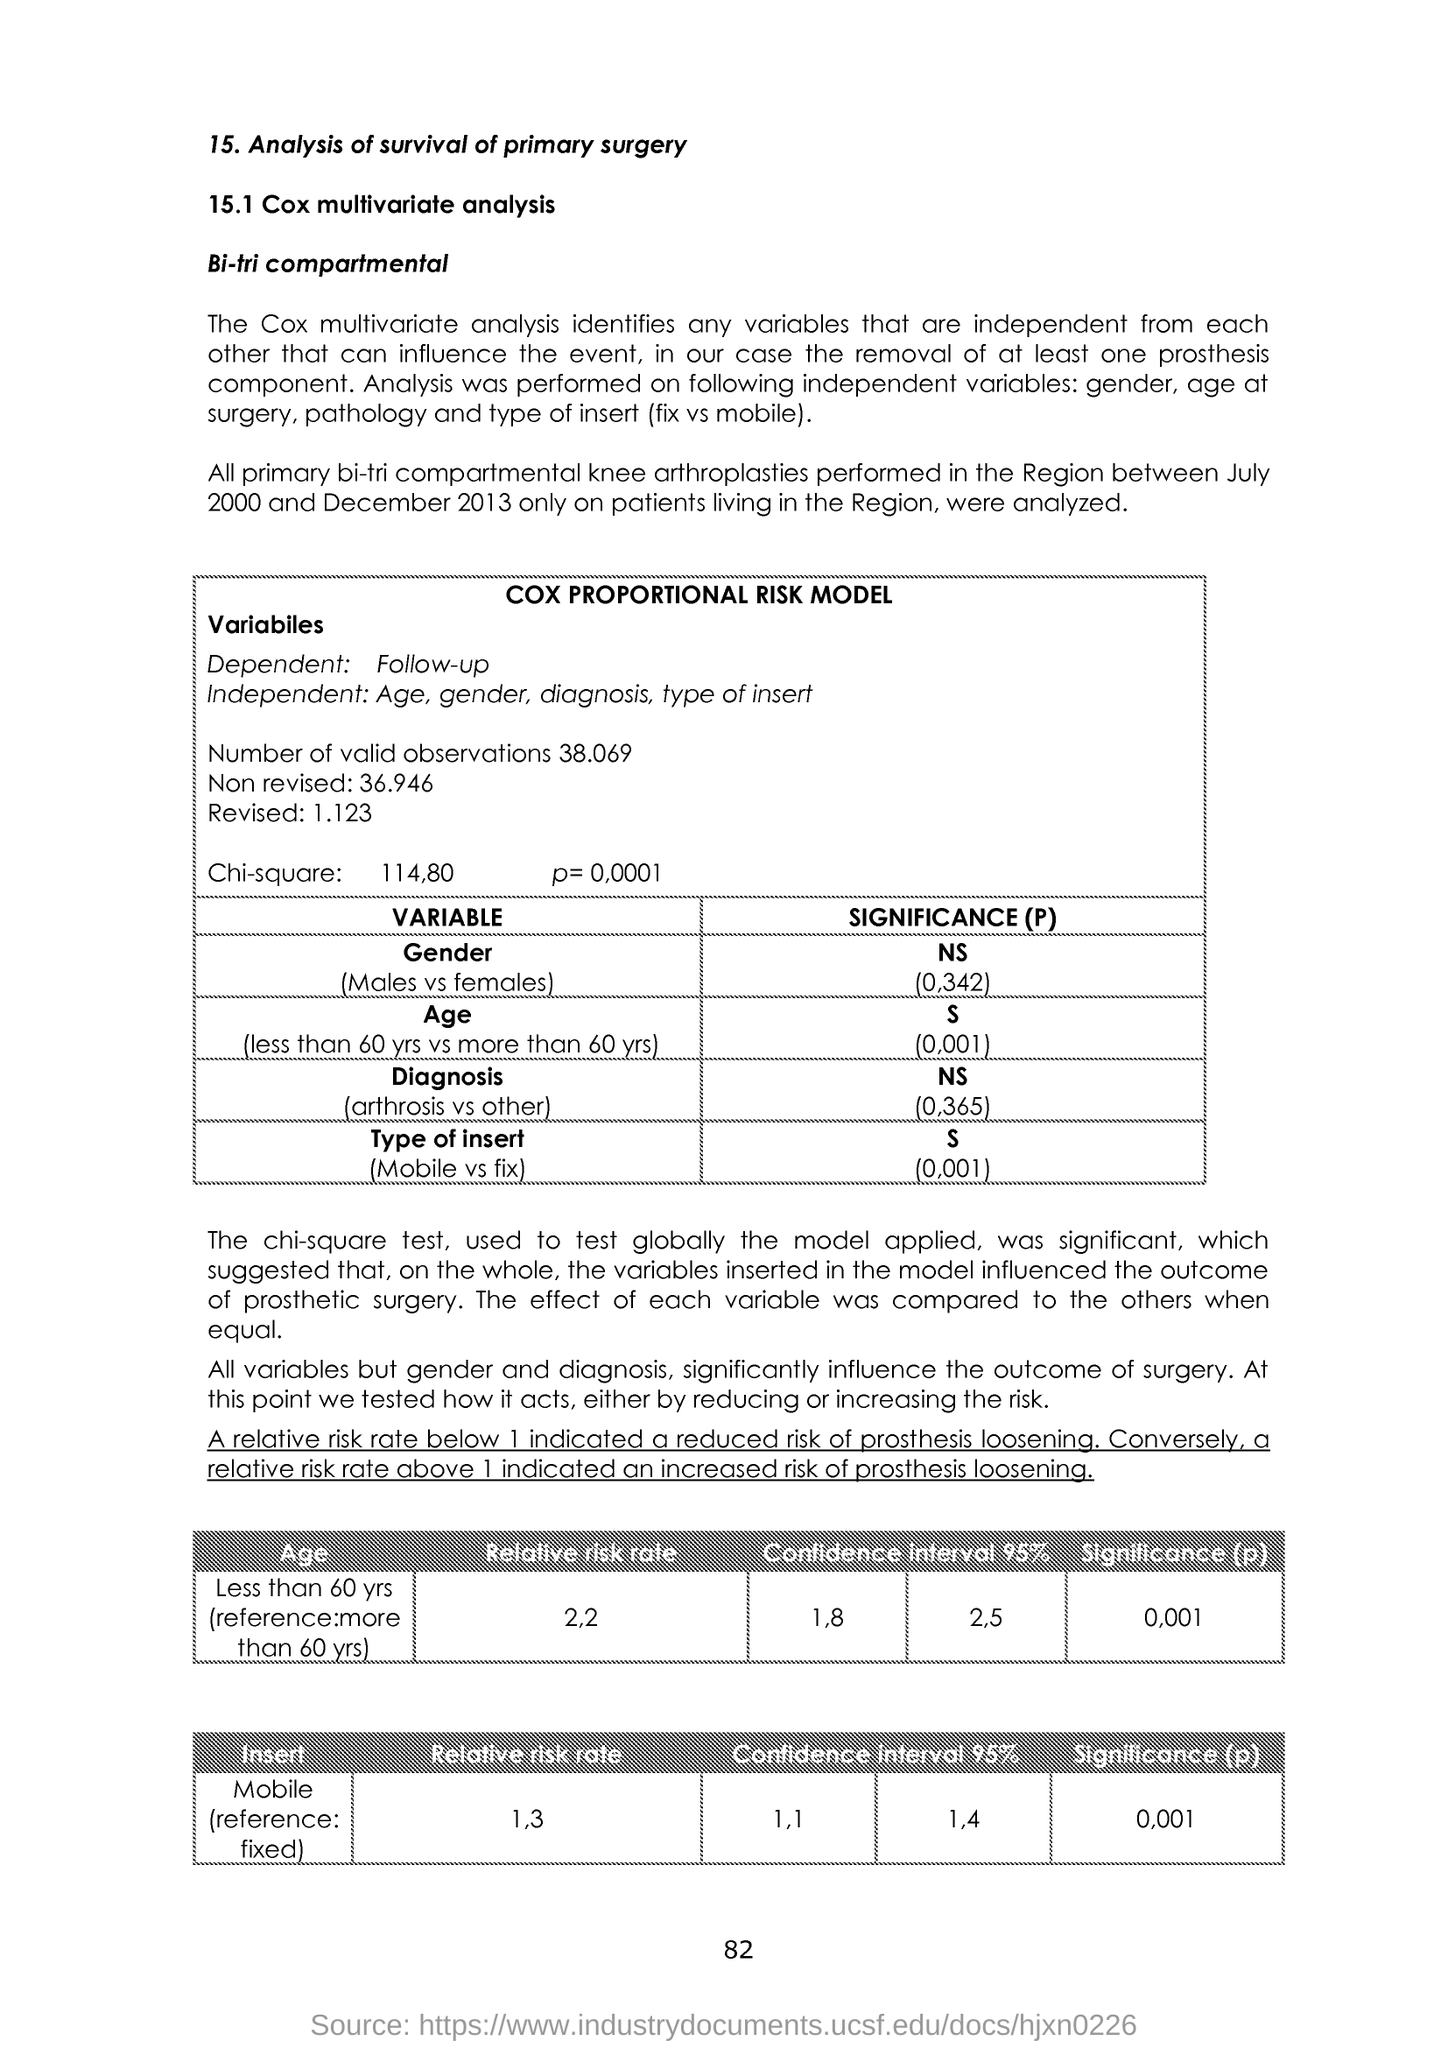What is the dependent variable?
Make the answer very short. Follow-up. What is the number of valid observations?
Provide a succinct answer. 38.069. What is the Chi-square value given?
Provide a succinct answer. 114,80. What was the relative risk rate in age less than 60 yrs?
Provide a short and direct response. 2,2. What was the significance value of Mobile insert?
Provide a succinct answer. (0.001). 